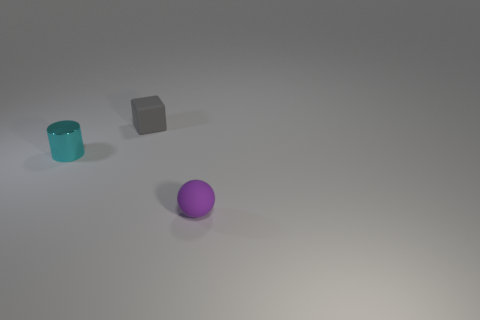Are there fewer tiny gray matte cubes to the left of the cyan shiny thing than small spheres behind the tiny gray matte cube?
Provide a succinct answer. No. How many other objects are the same shape as the purple object?
Your answer should be very brief. 0. How big is the matte thing in front of the rubber object that is on the left side of the thing that is right of the gray cube?
Provide a short and direct response. Small. How many brown objects are tiny matte things or tiny things?
Ensure brevity in your answer.  0. The rubber object that is on the right side of the tiny matte thing behind the rubber sphere is what shape?
Provide a short and direct response. Sphere. Is there a sphere that has the same material as the cube?
Offer a very short reply. Yes. Is there a cube that is to the left of the tiny thing that is right of the tiny matte thing behind the matte sphere?
Offer a terse response. Yes. There is a tiny purple thing; are there any purple rubber objects on the left side of it?
Give a very brief answer. No. There is a tiny rubber object behind the small purple thing; what number of balls are in front of it?
Keep it short and to the point. 1. There is a cyan object; does it have the same size as the rubber thing to the left of the small purple rubber object?
Your response must be concise. Yes. 